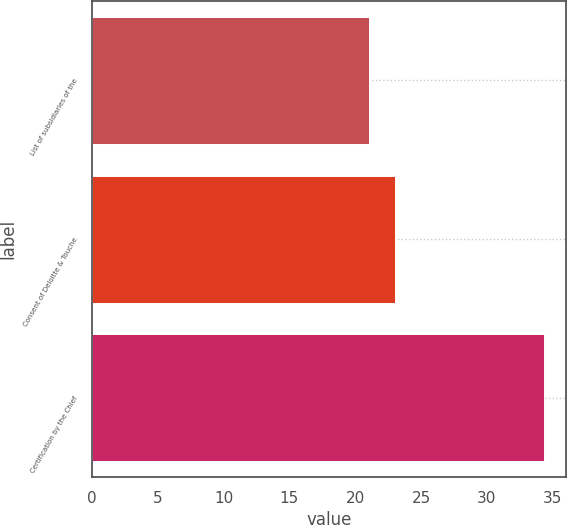Convert chart to OTSL. <chart><loc_0><loc_0><loc_500><loc_500><bar_chart><fcel>List of subsidiaries of the<fcel>Consent of Deloitte & Touche<fcel>Certification by the Chief<nl><fcel>21.01<fcel>23.01<fcel>34.31<nl></chart> 